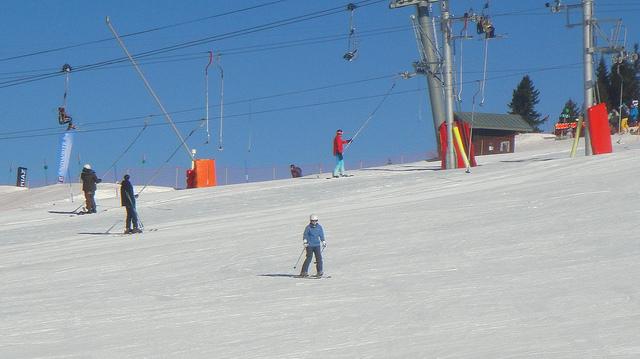Is there any house in the picture?
Quick response, please. Yes. What activity are these people doing?
Quick response, please. Skiing. Are there any trees visible in this picture?
Quick response, please. Yes. 